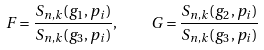Convert formula to latex. <formula><loc_0><loc_0><loc_500><loc_500>F = \frac { S _ { n , k } ( g _ { 1 } , p _ { i } ) } { S _ { n , k } ( g _ { 3 } , p _ { i } ) } , \quad G = \frac { S _ { n , k } ( g _ { 2 } , p _ { i } ) } { S _ { n , k } ( g _ { 3 } , p _ { i } ) }</formula> 